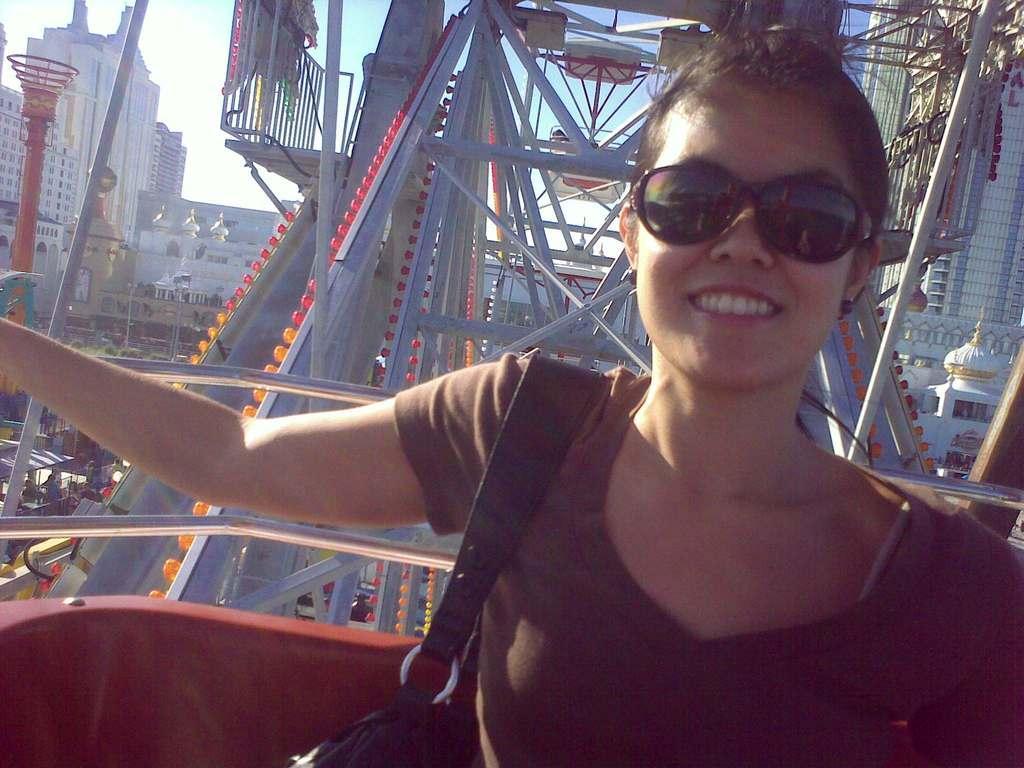Please provide a concise description of this image. In this picture we can see a woman sitting behind we can see some rods, side we can see so many buildings. 